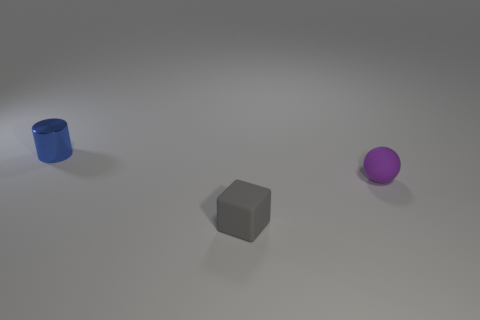Is there a tiny sphere that has the same material as the gray block?
Make the answer very short. Yes. There is a small blue thing; what shape is it?
Provide a succinct answer. Cylinder. How many small blocks are there?
Your answer should be very brief. 1. The rubber object in front of the tiny thing right of the small gray matte block is what color?
Your answer should be compact. Gray. There is a cylinder that is the same size as the purple object; what is its color?
Keep it short and to the point. Blue. Are there any small metallic things of the same color as the small block?
Give a very brief answer. No. Are any tiny matte spheres visible?
Your response must be concise. Yes. What is the shape of the gray matte object in front of the small purple rubber ball?
Your response must be concise. Cube. How many objects are both to the left of the ball and right of the cylinder?
Your answer should be compact. 1. What number of other things are the same size as the purple object?
Ensure brevity in your answer.  2. 